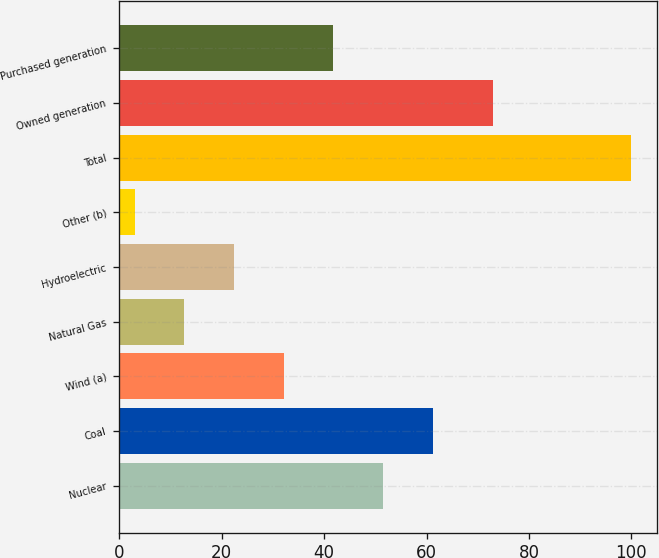<chart> <loc_0><loc_0><loc_500><loc_500><bar_chart><fcel>Nuclear<fcel>Coal<fcel>Wind (a)<fcel>Natural Gas<fcel>Hydroelectric<fcel>Other (b)<fcel>Total<fcel>Owned generation<fcel>Purchased generation<nl><fcel>51.5<fcel>61.2<fcel>32.1<fcel>12.7<fcel>22.4<fcel>3<fcel>100<fcel>73<fcel>41.8<nl></chart> 